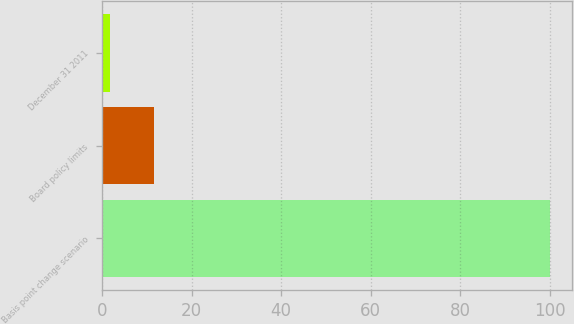<chart> <loc_0><loc_0><loc_500><loc_500><bar_chart><fcel>Basis point change scenario<fcel>Board policy limits<fcel>December 31 2011<nl><fcel>100<fcel>11.62<fcel>1.8<nl></chart> 